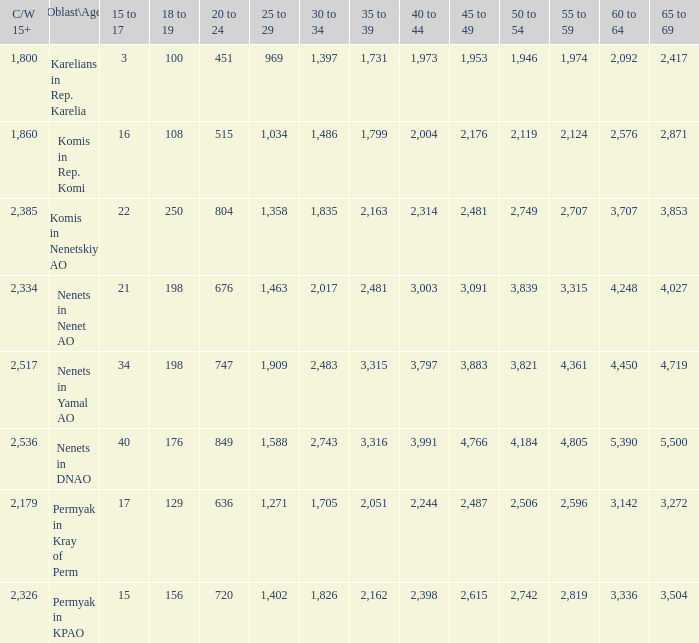Parse the full table. {'header': ['C/W 15+', 'Oblast\\Age', '15 to 17', '18 to 19', '20 to 24', '25 to 29', '30 to 34', '35 to 39', '40 to 44', '45 to 49', '50 to 54', '55 to 59', '60 to 64', '65 to 69'], 'rows': [['1,800', 'Karelians in Rep. Karelia', '3', '100', '451', '969', '1,397', '1,731', '1,973', '1,953', '1,946', '1,974', '2,092', '2,417'], ['1,860', 'Komis in Rep. Komi', '16', '108', '515', '1,034', '1,486', '1,799', '2,004', '2,176', '2,119', '2,124', '2,576', '2,871'], ['2,385', 'Komis in Nenetskiy AO', '22', '250', '804', '1,358', '1,835', '2,163', '2,314', '2,481', '2,749', '2,707', '3,707', '3,853'], ['2,334', 'Nenets in Nenet AO', '21', '198', '676', '1,463', '2,017', '2,481', '3,003', '3,091', '3,839', '3,315', '4,248', '4,027'], ['2,517', 'Nenets in Yamal AO', '34', '198', '747', '1,909', '2,483', '3,315', '3,797', '3,883', '3,821', '4,361', '4,450', '4,719'], ['2,536', 'Nenets in DNAO', '40', '176', '849', '1,588', '2,743', '3,316', '3,991', '4,766', '4,184', '4,805', '5,390', '5,500'], ['2,179', 'Permyak in Kray of Perm', '17', '129', '636', '1,271', '1,705', '2,051', '2,244', '2,487', '2,506', '2,596', '3,142', '3,272'], ['2,326', 'Permyak in KPAO', '15', '156', '720', '1,402', '1,826', '2,162', '2,398', '2,615', '2,742', '2,819', '3,336', '3,504']]} With a 35 to 39 greater than 3,315 what is the 45 to 49? 4766.0. 